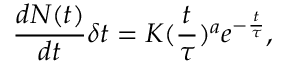<formula> <loc_0><loc_0><loc_500><loc_500>\frac { d N ( t ) } { d t } \delta t = K ( \frac { t } { \tau } ) ^ { a } e ^ { - \frac { t } { \tau } } ,</formula> 